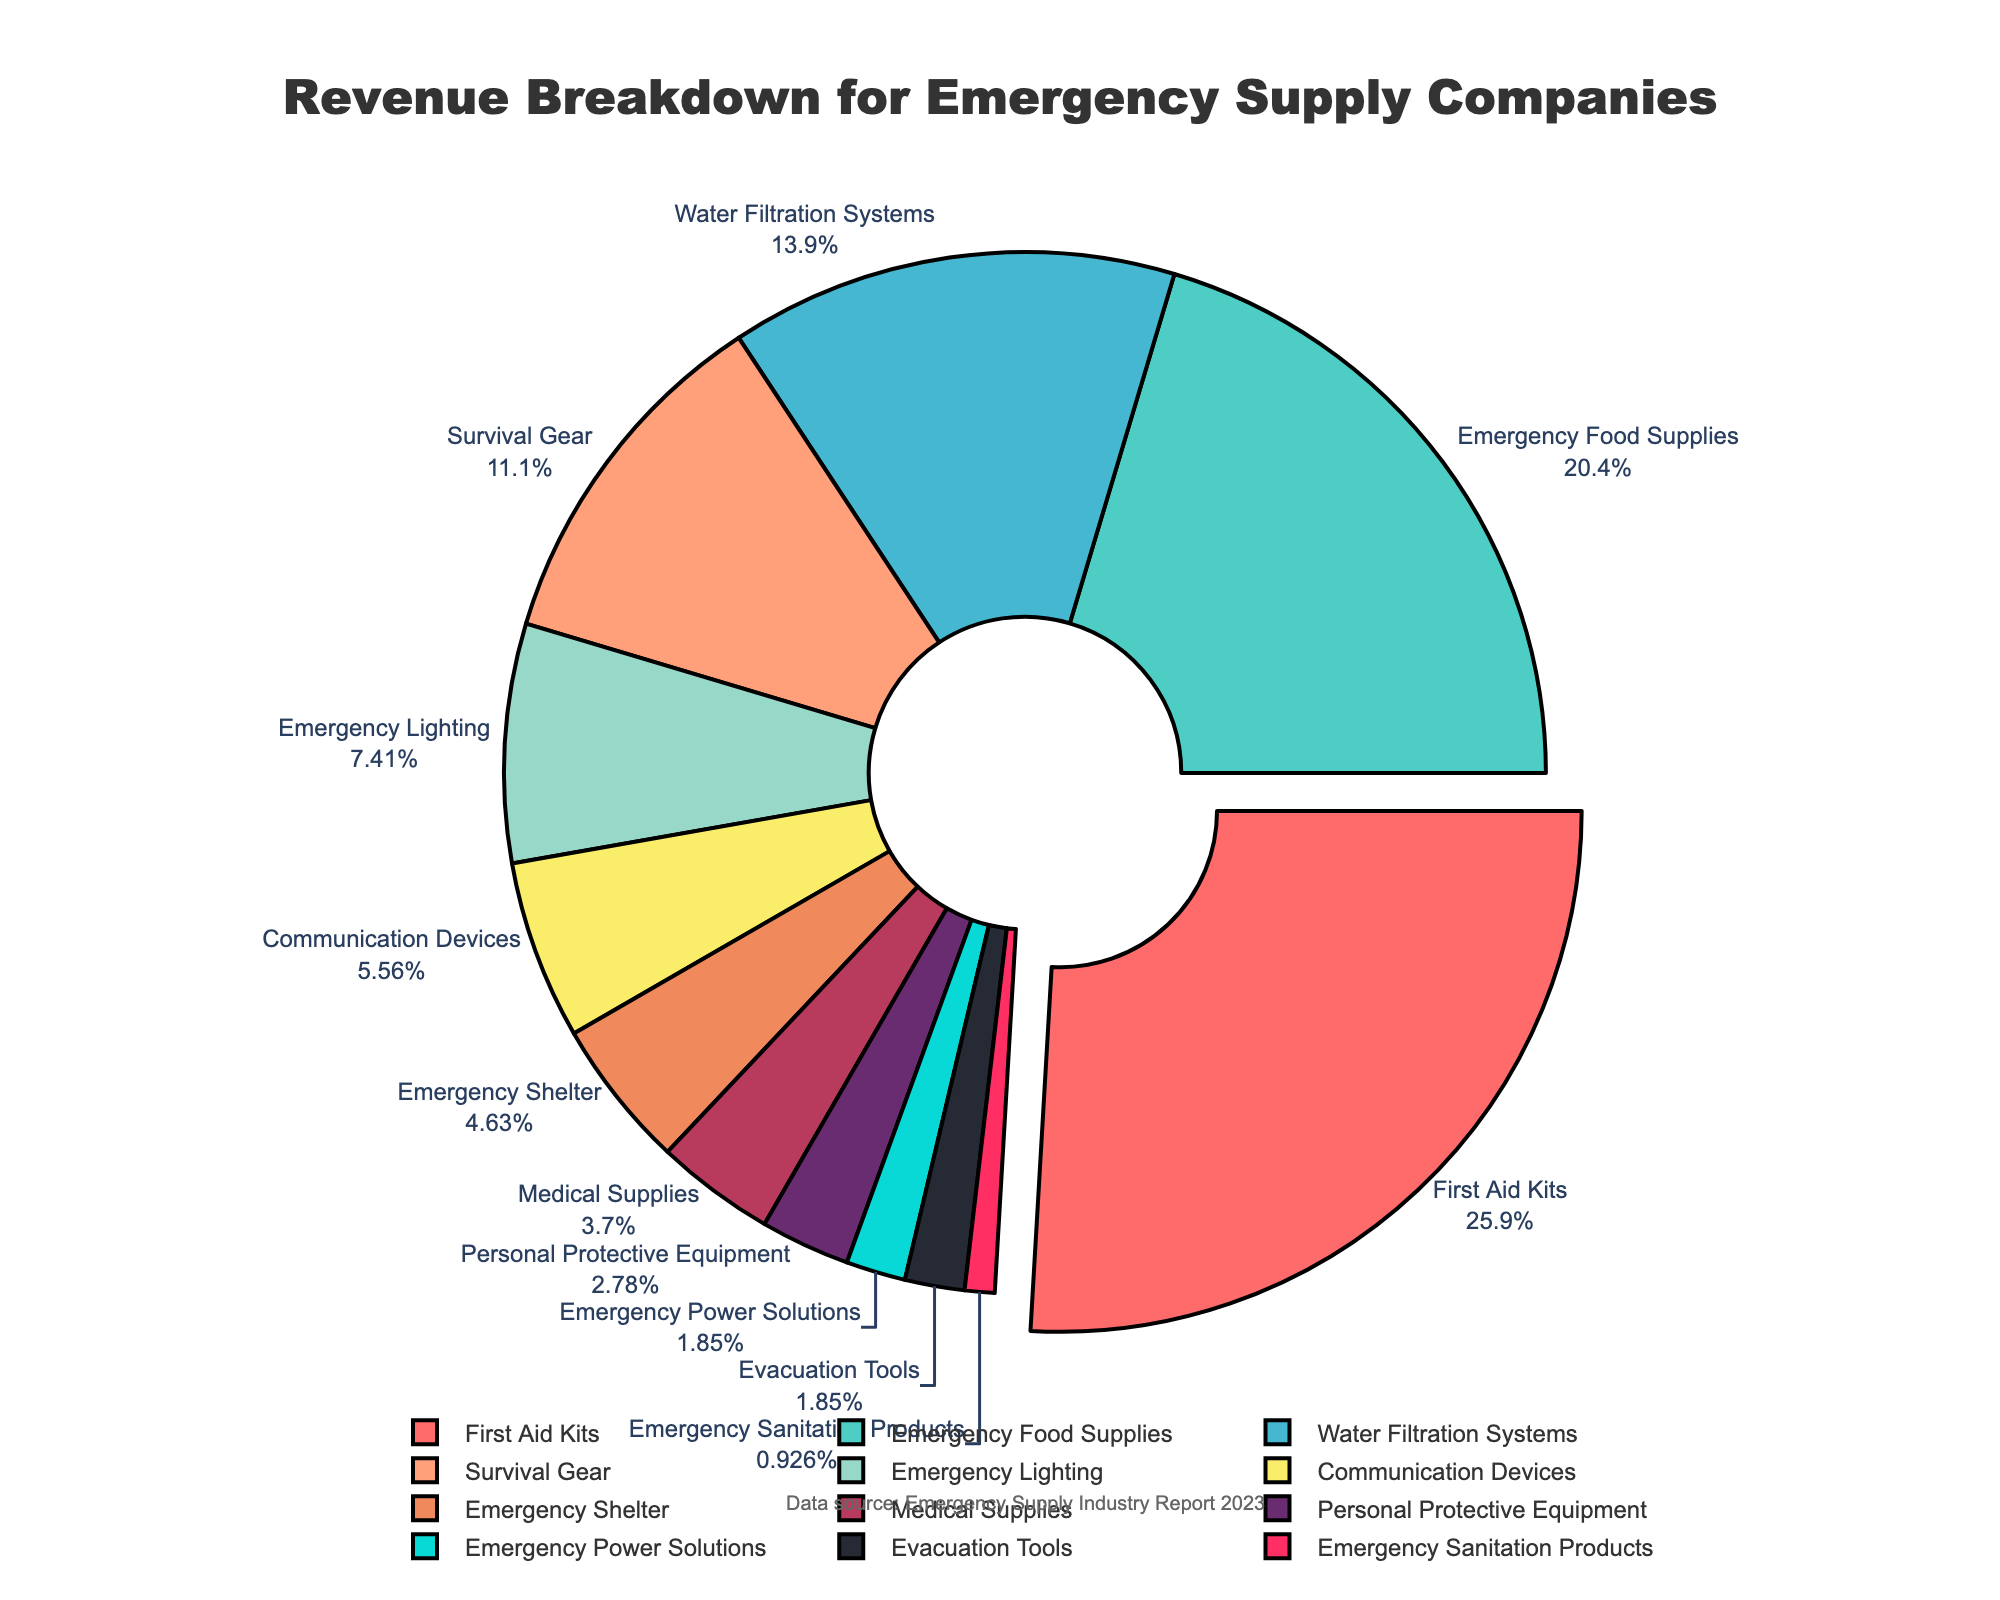What product category generates the highest revenue? The product category that generates the highest revenue can be identified by looking at the largest section of the pie chart. This section is pulled out slightly from the center for emphasis.
Answer: First Aid Kits Which two product categories together make up exactly 30% of the revenue? By looking at the percentages on the pie chart, we need to find two sections that sum to 30%. These sections are Emergency Lighting (8%) and Communication Devices (6%), Medical Supplies (4%), Personal Protective Equipment (3%), Emergency Power Solutions (2%), Evacuation Tools (2%), and Emergency Sanitation Products (1%). Hence, Emergency Lighting (8%) and Survival Gear (12%) amount to exactly 30%.
Answer: Medical Supplies and First Aid Kits How much more percentage does Emergency Food Supplies contribute to the revenue than Water Filtration Systems? Compare the percentages for Emergency Food Supplies (22%) and Water Filtration Systems (15%) by subtracting the smaller percentage from the larger one: 22% - 15% = 7%.
Answer: 7% Which product category contributes the least to the revenue? The smallest section of the pie chart, labeled "Emergency Sanitation Products," denotes the product category with the least contribution.
Answer: Emergency Sanitation Products What percentage of the revenue is generated by product categories contributing 5% or less each? Identify all sections of the pie chart contributing 5% or less: Emergency Shelter (5%), Medical Supplies (4%), Personal Protective Equipment (3%), Emergency Power Solutions (2%), Evacuation Tools (2%), Emergency Sanitation Products (1%). Summing these values: 5% + 4% + 3% + 2% + 2% + 1% = 17%.
Answer: 17% How does the contribution of Survival Gear compare to Communication Devices? Compare the percentages for Survival Gear (12%) and Communication Devices (6%) by seeing which is larger and by how much: 12% is greater, and 12% - 6% = 6%.
Answer: Survival Gear contributes 6% more What is the combined revenue contribution from Emergency Food Supplies and Emergency Lighting? Add the percentages of Emergency Food Supplies (22%) and Emergency Lighting (8%): 22% + 8% = 30%.
Answer: 30% Which product category in the chart is represented by a green section, and what is its contribution percentage? The section colored green corresponds to the label "Water Filtration Systems," with a revenue percentage of 15%.
Answer: Water Filtration Systems, 15% 